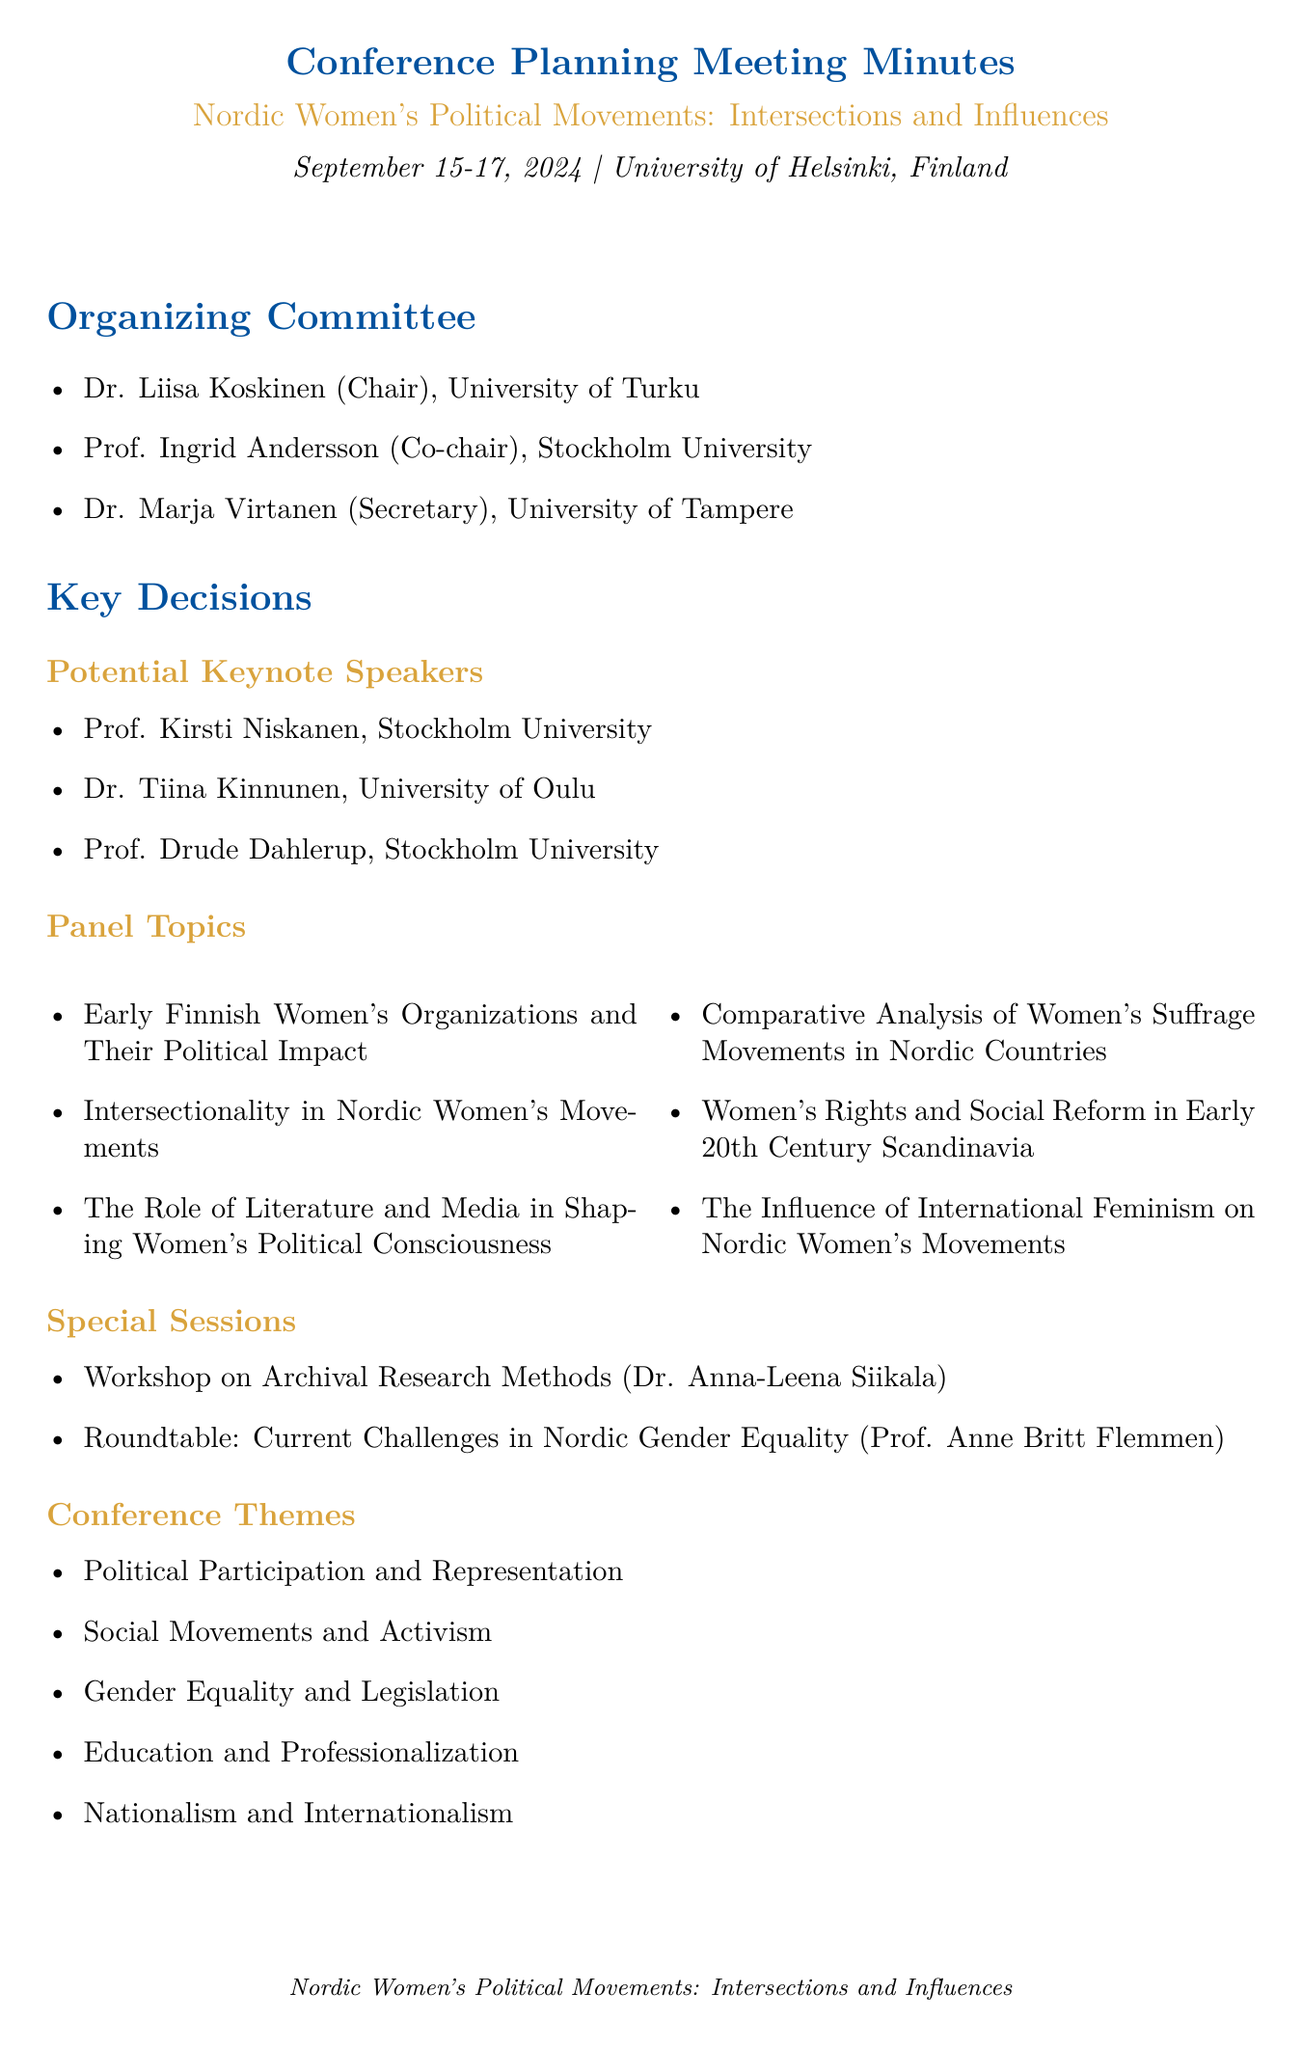What is the conference title? The title is explicitly mentioned at the beginning of the document.
Answer: Nordic Women's Political Movements: Intersections and Influences When will the conference take place? The date is stated clearly in the document.
Answer: September 15-17, 2024 Who is the chair of the organizing committee? The document lists the members of the organizing committee along with their roles.
Answer: Dr. Liisa Koskinen What is one proposed panel topic? The document outlines multiple panel topics.
Answer: Early Finnish Women's Organizations and Their Political Impact Who is the editor for the publication plans? The document specifies the editor associated with the publication plans.
Answer: Prof. Mary Hilson How many potential keynote speakers are listed? The number can be counted from the section on potential keynote speakers.
Answer: Three What institution is facilitating the workshop on archival research methods? The document identifies the facilitator and their affiliation for the workshop.
Answer: University of Helsinki What are the funding sources for the conference? The document enumerates the sources of funding available for this conference.
Answer: Nordic Council of Ministers, Finnish Academy of Science and Letters, Swedish Research Council 